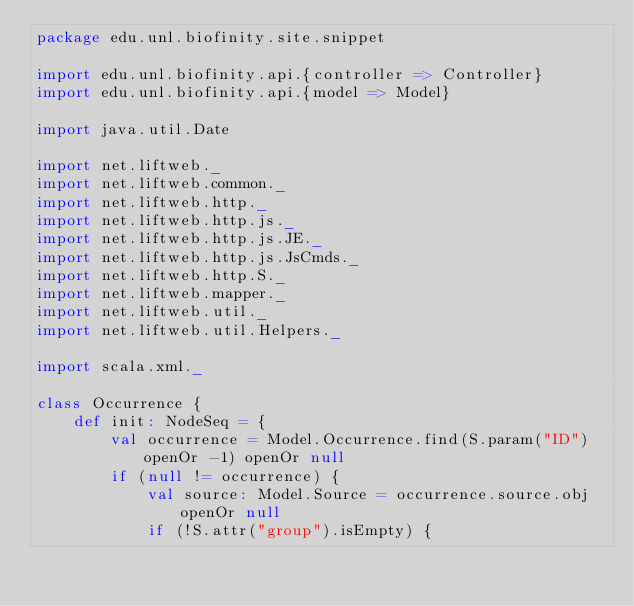Convert code to text. <code><loc_0><loc_0><loc_500><loc_500><_Scala_>package edu.unl.biofinity.site.snippet

import edu.unl.biofinity.api.{controller => Controller}
import edu.unl.biofinity.api.{model => Model}

import java.util.Date

import net.liftweb._
import net.liftweb.common._
import net.liftweb.http._
import net.liftweb.http.js._
import net.liftweb.http.js.JE._
import net.liftweb.http.js.JsCmds._
import net.liftweb.http.S._
import net.liftweb.mapper._
import net.liftweb.util._
import net.liftweb.util.Helpers._

import scala.xml._

class Occurrence {
	def init: NodeSeq = {
		val occurrence = Model.Occurrence.find(S.param("ID") openOr -1) openOr null
		if (null != occurrence) {
			val source: Model.Source = occurrence.source.obj openOr null
			if (!S.attr("group").isEmpty) {</code> 